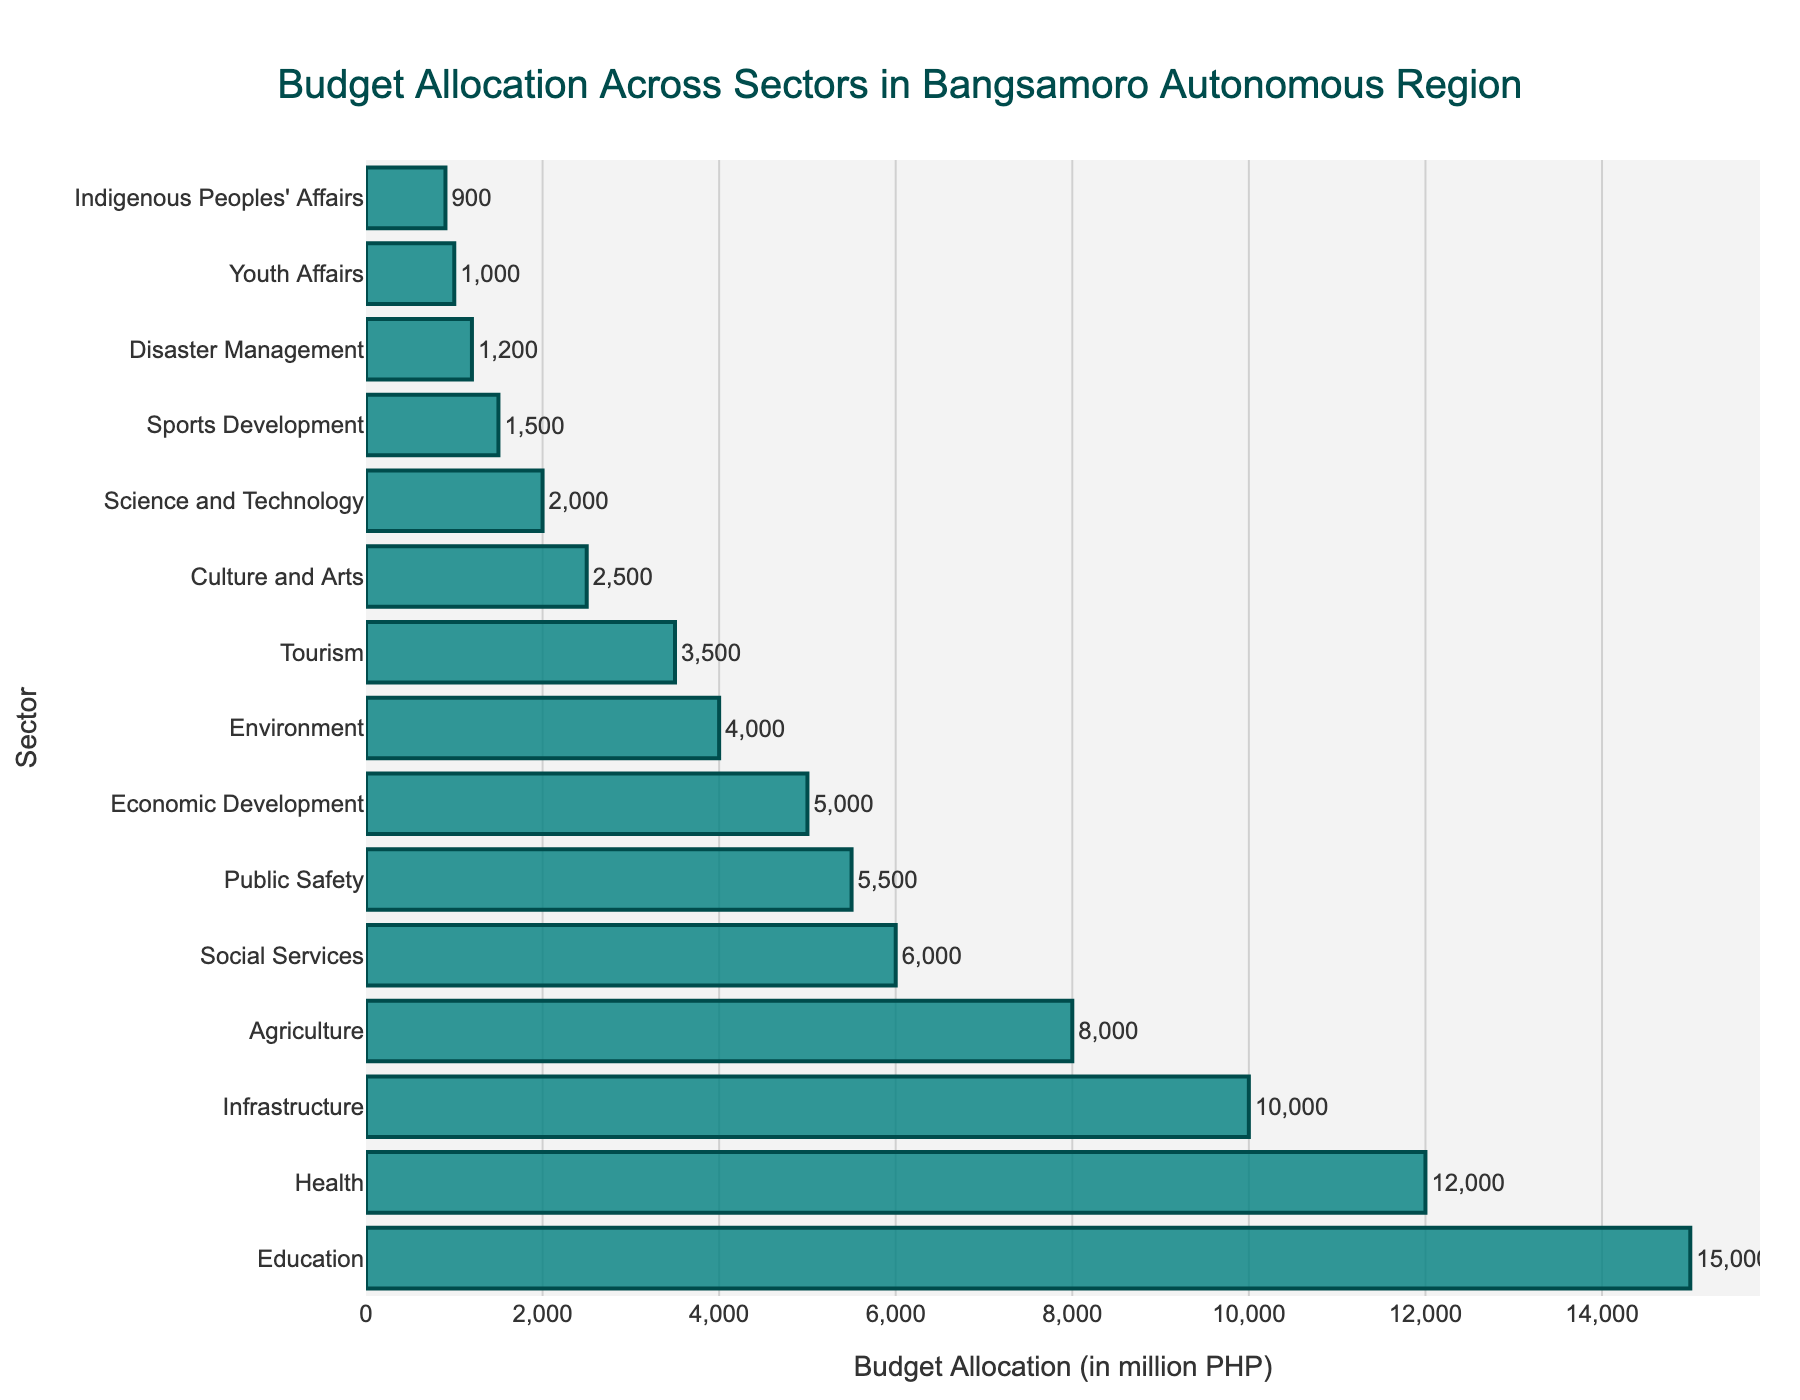What sector has the highest budget allocation? The sector with the highest budget allocation is the one with the longest bar on the plot. By inspecting the figure, the Education sector has the longest bar.
Answer: Education What is the total budget allocation for Health and Public Safety? Find the budget allocations for Health and Public Safety by looking at their corresponding bars. Health has 12,000 million PHP and Public Safety has 5,500 million PHP. Adding these values gives 17,500 million PHP.
Answer: 17,500 million PHP Which sector has a smaller budget allocation, Agriculture or Social Services? Compare the lengths of the corresponding bars. The bar for Social Services is shorter than the bar for Agriculture. Hence, the budget for Social Services is smaller.
Answer: Social Services Which sectors have a budget allocation greater than 10,000 million PHP? Identify bars representing sectors with budget allocations greater than 10,000 million PHP. The Education, Health, and Infrastructure sectors meet this criterion.
Answer: Education, Health, Infrastructure What is the difference in budget allocation between Infrastructure and Environment? Find their budget allocations: Infrastructure has 10,000 million PHP and Environment has 4,000 million PHP. Subtracting these gives 10,000 - 4,000 = 6,000 million PHP.
Answer: 6,000 million PHP How much is the combined budget allocation for Tourism, Culture and Arts, and Science and Technology? Find the budget allocations for each: Tourism (3,500 million PHP), Culture and Arts (2,500 million PHP), and Science and Technology (2,000 million PHP). Adding these gives 3,500 + 2,500 + 2,000 = 8,000 million PHP.
Answer: 8,000 million PHP Is the budget allocated for Economic Development greater or smaller than for Public Safety? Compare the lengths of the bars. The bar for Public Safety is longer than the bar for Economic Development, so its budget allocation is greater.
Answer: Smaller What is the average budget allocation for the top three sectors? The top three sectors are Education (15,000 million PHP), Health (12,000 million PHP), and Infrastructure (10,000 million PHP). Their average is (15,000 + 12,000 + 10,000) / 3 = 37,000 / 3 ≈ 12,333.33 million PHP.
Answer: 12,333.33 million PHP Which sector has around one-sixth of the budget allocation of the Education sector? One-sixth of Education's budget (15,000 million PHP) is 15,000 / 6 = 2,500 million PHP. By inspecting the bars, the Culture and Arts sector has approximately 2,500 million PHP.
Answer: Culture and Arts 